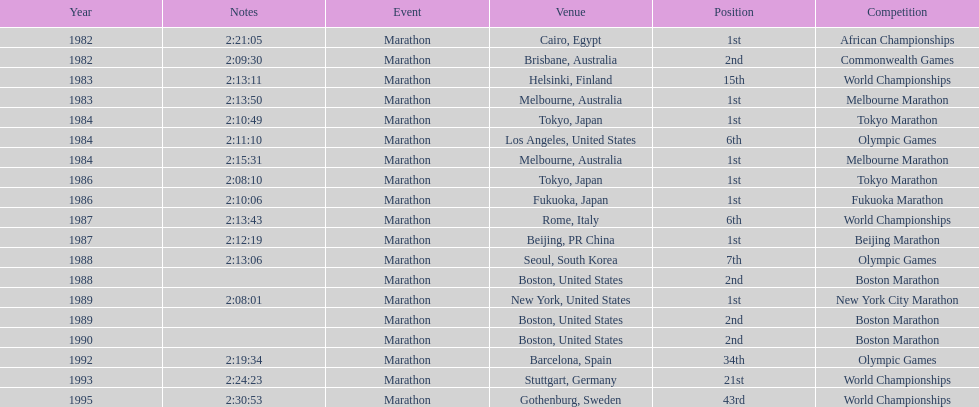In which year did the athlete take part in the highest number of marathons? 1984. 